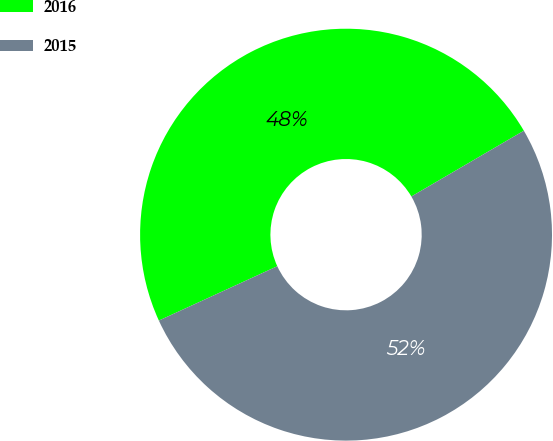Convert chart. <chart><loc_0><loc_0><loc_500><loc_500><pie_chart><fcel>2016<fcel>2015<nl><fcel>48.43%<fcel>51.57%<nl></chart> 